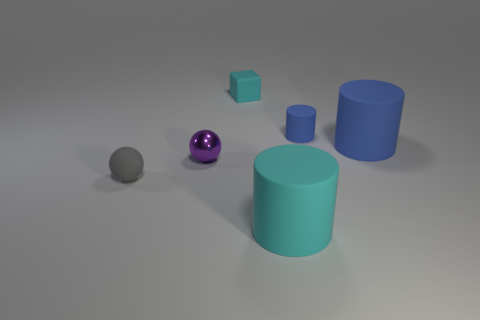Are there any other things that are made of the same material as the small purple sphere?
Offer a very short reply. No. Is the number of big blue matte cylinders behind the cube less than the number of small matte things that are to the left of the big cyan cylinder?
Offer a terse response. Yes. Is the big thing behind the purple metal thing made of the same material as the ball that is on the right side of the small gray matte ball?
Provide a short and direct response. No. What number of large things are purple spheres or gray matte objects?
Your answer should be compact. 0. What is the shape of the tiny cyan thing that is made of the same material as the tiny gray object?
Your answer should be compact. Cube. Is the number of tiny gray matte objects on the left side of the gray sphere less than the number of big red cylinders?
Keep it short and to the point. No. Do the large blue object and the tiny gray rubber object have the same shape?
Your answer should be very brief. No. What number of metallic objects are cyan objects or big cyan things?
Keep it short and to the point. 0. Are there any gray rubber objects of the same size as the cube?
Your response must be concise. Yes. What number of gray metallic balls are the same size as the cyan cylinder?
Provide a short and direct response. 0. 